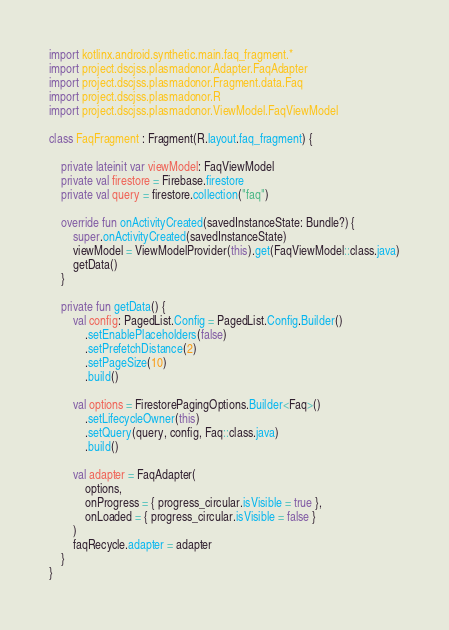Convert code to text. <code><loc_0><loc_0><loc_500><loc_500><_Kotlin_>import kotlinx.android.synthetic.main.faq_fragment.*
import project.dscjss.plasmadonor.Adapter.FaqAdapter
import project.dscjss.plasmadonor.Fragment.data.Faq
import project.dscjss.plasmadonor.R
import project.dscjss.plasmadonor.ViewModel.FaqViewModel

class FaqFragment : Fragment(R.layout.faq_fragment) {

    private lateinit var viewModel: FaqViewModel
    private val firestore = Firebase.firestore
    private val query = firestore.collection("faq")

    override fun onActivityCreated(savedInstanceState: Bundle?) {
        super.onActivityCreated(savedInstanceState)
        viewModel = ViewModelProvider(this).get(FaqViewModel::class.java)
        getData()
    }

    private fun getData() {
        val config: PagedList.Config = PagedList.Config.Builder()
            .setEnablePlaceholders(false)
            .setPrefetchDistance(2)
            .setPageSize(10)
            .build()

        val options = FirestorePagingOptions.Builder<Faq>()
            .setLifecycleOwner(this)
            .setQuery(query, config, Faq::class.java)
            .build()

        val adapter = FaqAdapter(
            options,
            onProgress = { progress_circular.isVisible = true },
            onLoaded = { progress_circular.isVisible = false }
        )
        faqRecycle.adapter = adapter
    }
}
</code> 